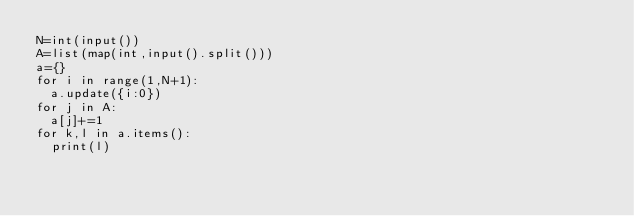Convert code to text. <code><loc_0><loc_0><loc_500><loc_500><_Python_>N=int(input())
A=list(map(int,input().split()))
a={}
for i in range(1,N+1):
  a.update({i:0})
for j in A:
  a[j]+=1
for k,l in a.items():
  print(l)</code> 